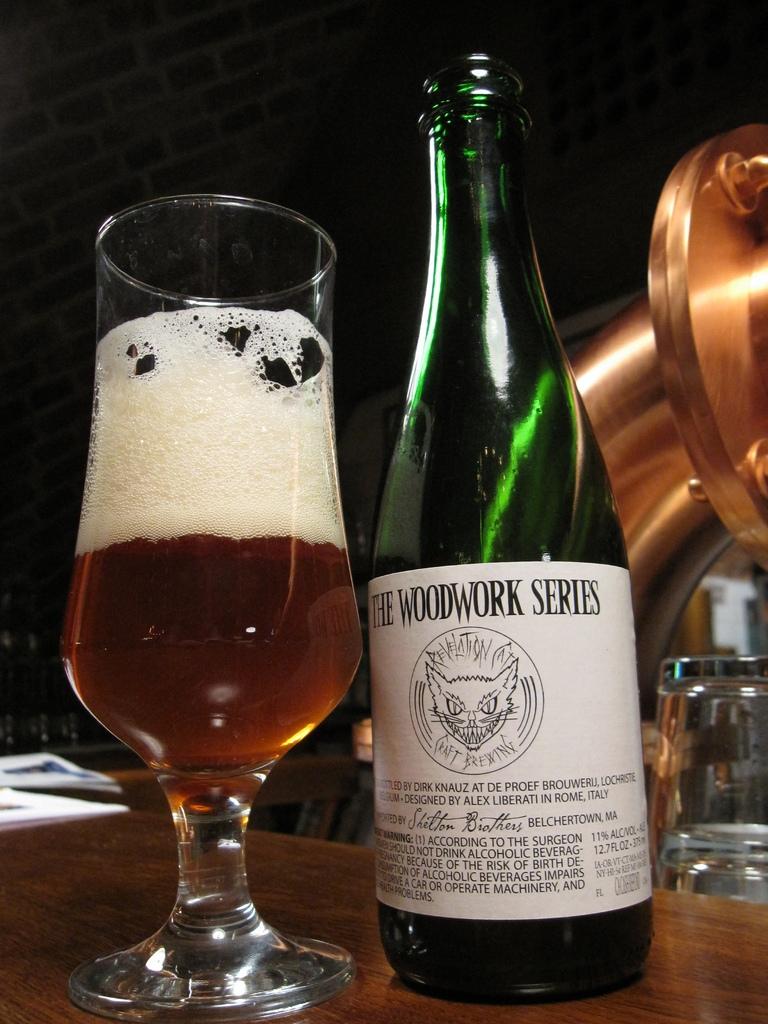What's the brand of wine?
Ensure brevity in your answer.  The woodwork series. What series of wine is this?
Offer a very short reply. Woodwork. 